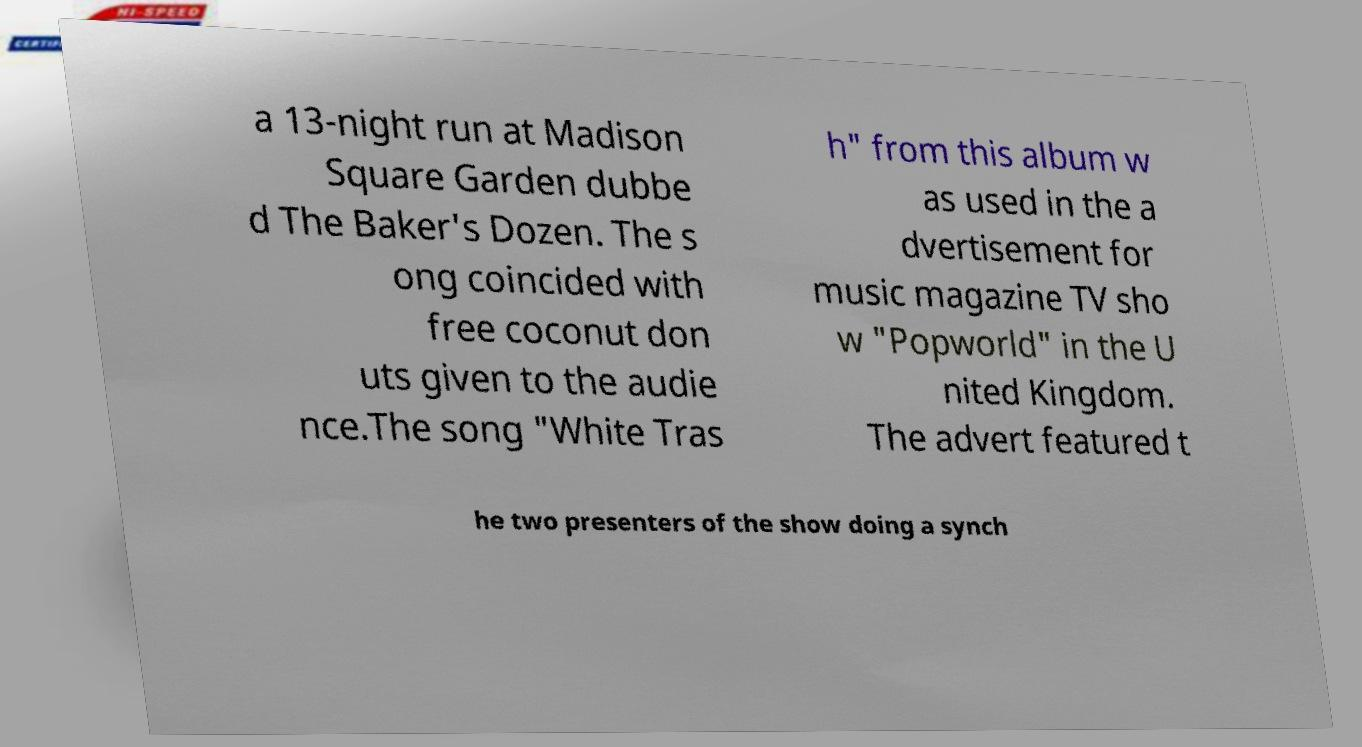I need the written content from this picture converted into text. Can you do that? a 13-night run at Madison Square Garden dubbe d The Baker's Dozen. The s ong coincided with free coconut don uts given to the audie nce.The song "White Tras h" from this album w as used in the a dvertisement for music magazine TV sho w "Popworld" in the U nited Kingdom. The advert featured t he two presenters of the show doing a synch 